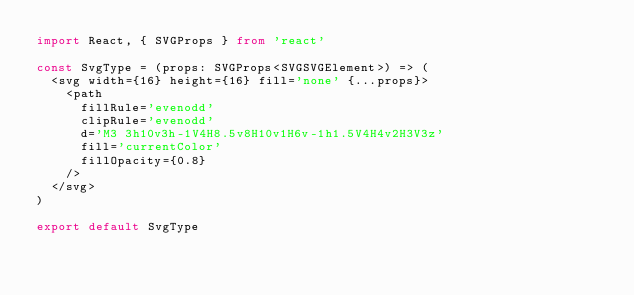<code> <loc_0><loc_0><loc_500><loc_500><_TypeScript_>import React, { SVGProps } from 'react'

const SvgType = (props: SVGProps<SVGSVGElement>) => (
  <svg width={16} height={16} fill='none' {...props}>
    <path
      fillRule='evenodd'
      clipRule='evenodd'
      d='M3 3h10v3h-1V4H8.5v8H10v1H6v-1h1.5V4H4v2H3V3z'
      fill='currentColor'
      fillOpacity={0.8}
    />
  </svg>
)

export default SvgType
</code> 